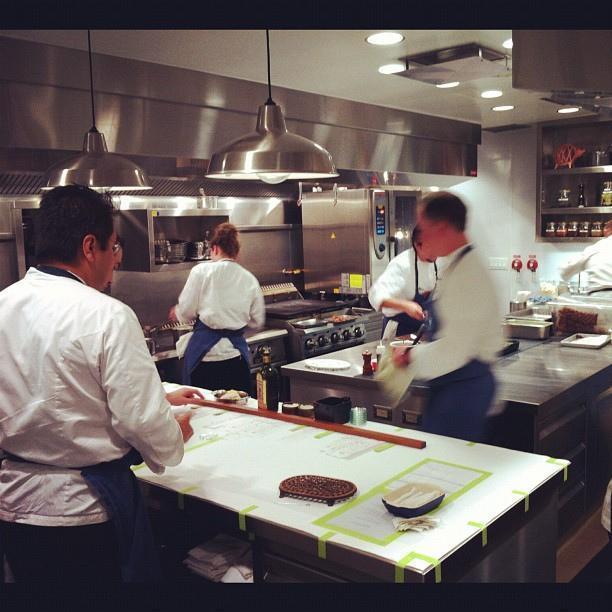How many people are pictured?
Give a very brief answer. 5. How many lights hanging from the ceiling?
Give a very brief answer. 2. How many ovens can you see?
Give a very brief answer. 2. How many dining tables are there?
Give a very brief answer. 3. How many people are there?
Give a very brief answer. 5. 